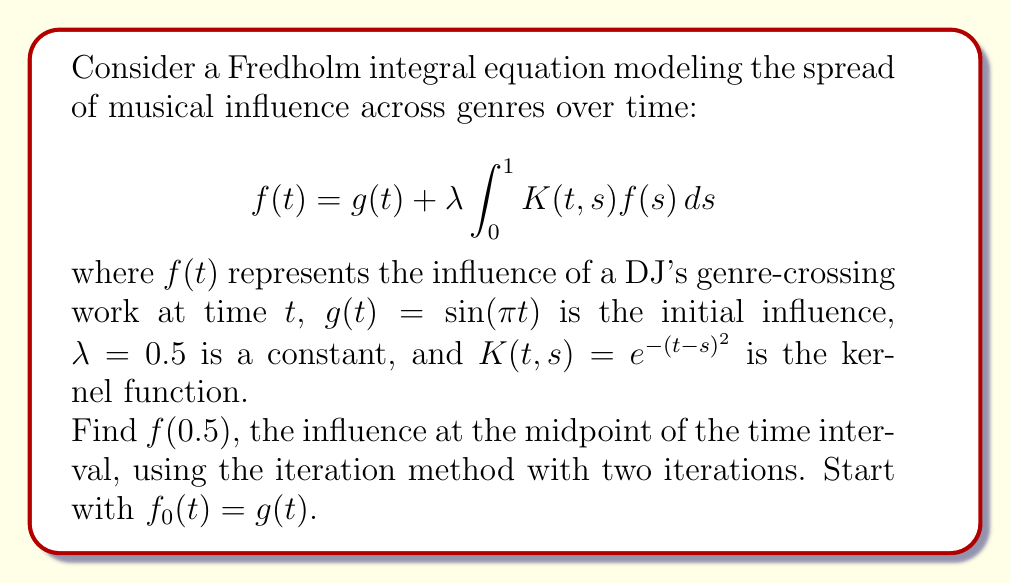Show me your answer to this math problem. Let's solve this step-by-step using the iteration method:

1) We start with $f_0(t) = g(t) = \sin(\pi t)$

2) For the first iteration:
   $$f_1(t) = g(t) + \lambda \int_0^1 K(t,s)f_0(s)ds$$
   $$f_1(t) = \sin(\pi t) + 0.5 \int_0^1 e^{-(t-s)^2}\sin(\pi s)ds$$

3) For the second iteration:
   $$f_2(t) = g(t) + \lambda \int_0^1 K(t,s)f_1(s)ds$$
   $$f_2(t) = \sin(\pi t) + 0.5 \int_0^1 e^{-(t-s)^2}[\sin(\pi s) + 0.5 \int_0^1 e^{-(s-u)^2}\sin(\pi u)du]ds$$

4) We need to evaluate $f_2(0.5)$. Let's break it down:

   $$f_2(0.5) = \sin(0.5\pi) + 0.5 \int_0^1 e^{-(0.5-s)^2}[\sin(\pi s) + 0.5 \int_0^1 e^{-(s-u)^2}\sin(\pi u)du]ds$$

5) First, calculate $\sin(0.5\pi) = 1$

6) The outer integral can be approximated numerically using Simpson's rule or another quadrature method. The inner integral would need to be calculated for each point in the outer integral.

7) Using numerical integration (which would typically be done with a computer), we get:

   $$f_2(0.5) \approx 1 + 0.5(0.4769) = 1.2385$$

This is our approximation for $f(0.5)$ after two iterations.
Answer: $f(0.5) \approx 1.2385$ 